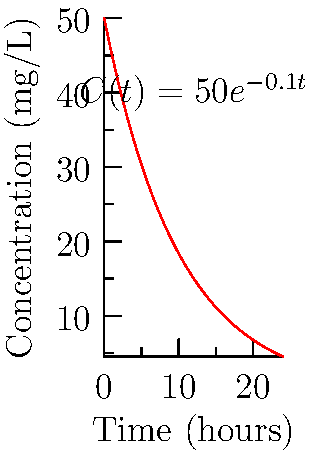A new drug's concentration in the bloodstream over time can be modeled by the function $C(t) = 50e^{-0.1t}$, where $C$ is the concentration in mg/L and $t$ is time in hours. Calculate the area under the curve (AUC) from $t=0$ to $t=24$ hours. This value is crucial for determining the drug's bioavailability and efficacy. Round your answer to the nearest whole number. To find the area under the curve (AUC), we need to integrate the concentration function from $t=0$ to $t=24$. Here's the step-by-step solution:

1) The integral we need to evaluate is:
   $$AUC = \int_0^{24} 50e^{-0.1t} dt$$

2) To integrate this, we can use the rule for integrating exponential functions:
   $$\int e^{ax} dx = \frac{1}{a}e^{ax} + C$$

3) Applying this rule to our integral:
   $$AUC = -500e^{-0.1t} \bigg|_0^{24}$$

4) Now we evaluate this from 0 to 24:
   $$AUC = (-500e^{-0.1(24)}) - (-500e^{-0.1(0)})$$

5) Simplify:
   $$AUC = -500e^{-2.4} + 500$$

6) Calculate:
   $$AUC \approx -500(0.0907) + 500 \approx 454.65$$

7) Rounding to the nearest whole number:
   $$AUC \approx 455$$

Therefore, the area under the curve from 0 to 24 hours is approximately 455 mg·h/L.
Answer: 455 mg·h/L 